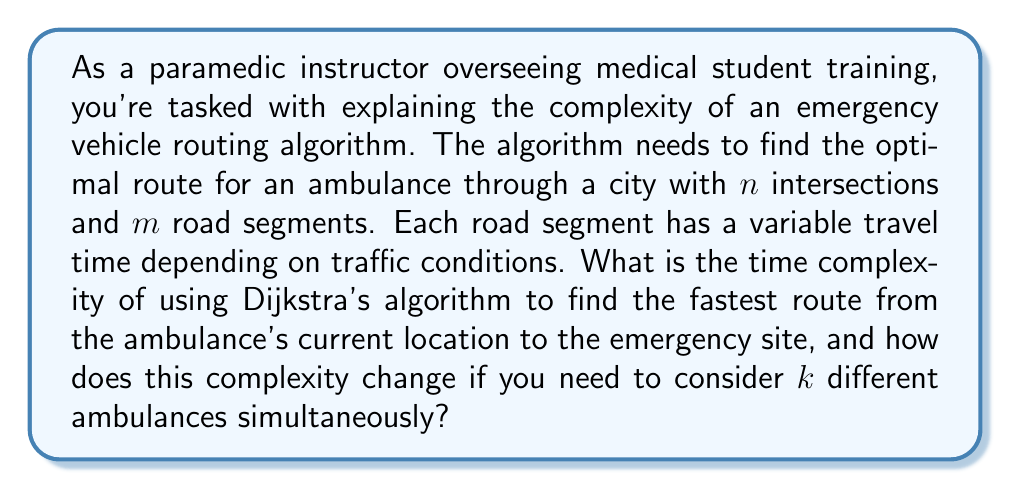Teach me how to tackle this problem. To solve this problem, we need to consider the following steps:

1. Modeling the city:
   The city can be represented as a graph where intersections are nodes and road segments are edges. Each edge has a weight representing the travel time.

2. Dijkstra's algorithm for a single ambulance:
   Dijkstra's algorithm finds the shortest path from a single source to all other nodes in a weighted graph.
   
   Time complexity of Dijkstra's algorithm:
   - Using a binary heap: $O((m + n) \log n)$
   - Using a Fibonacci heap: $O(m + n \log n)$

   Where $n$ is the number of nodes (intersections) and $m$ is the number of edges (road segments).

3. Considering $k$ ambulances:
   We need to run Dijkstra's algorithm $k$ times, once for each ambulance's starting position.

Therefore, the time complexity for $k$ ambulances becomes:
   - Using a binary heap: $O(k(m + n) \log n)$
   - Using a Fibonacci heap: $O(k(m + n \log n))$

This shows that the complexity scales linearly with the number of ambulances $k$.

In practice, for emergency routing, the Fibonacci heap implementation might be preferred due to its better asymptotic performance, especially for graphs with many more edges than vertices (which is common in city road networks).
Answer: The time complexity for routing a single ambulance using Dijkstra's algorithm is $O((m + n) \log n)$ with a binary heap or $O(m + n \log n)$ with a Fibonacci heap. For $k$ ambulances, the time complexity becomes $O(k(m + n) \log n)$ with a binary heap or $O(k(m + n \log n))$ with a Fibonacci heap. 